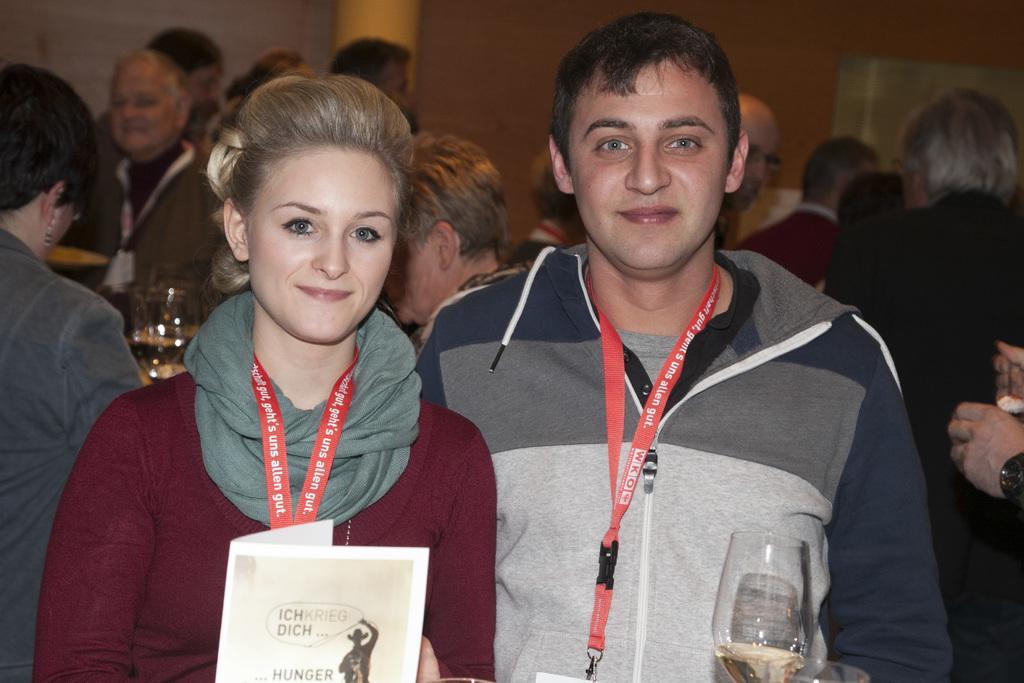In one or two sentences, can you explain what this image depicts? As we can see that women and men are posing for the photo. Women is catching paper in her hand and man is catching a wine glass in his hand. They both are wearing identity cards. Woman is wearing a maroon color dress and man is wearing gray color dress. And behind them the other people are busy in talking to others. 